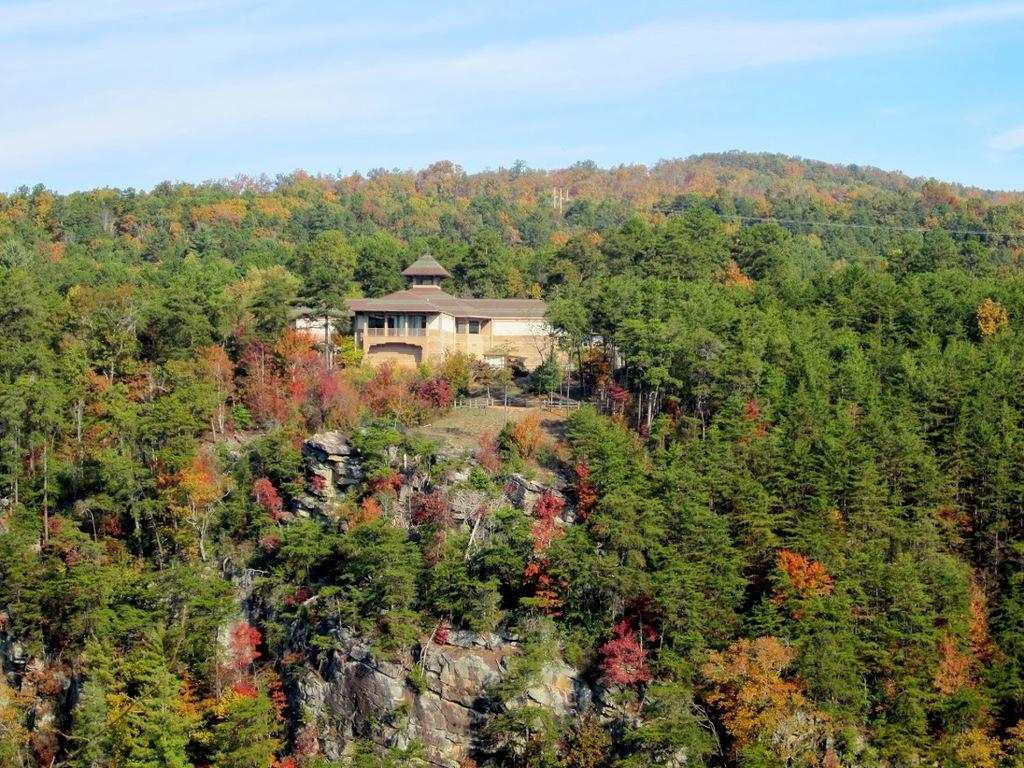What type of structure is present in the image? There is a house in the image. What other natural elements can be seen in the image? There are trees in the image. What is visible at the top of the image? The sky is visible at the top of the image. Where is the cactus located in the image? There is no cactus present in the image. What type of yard is featured in the image? The image does not show a yard; it only shows a house and trees. 